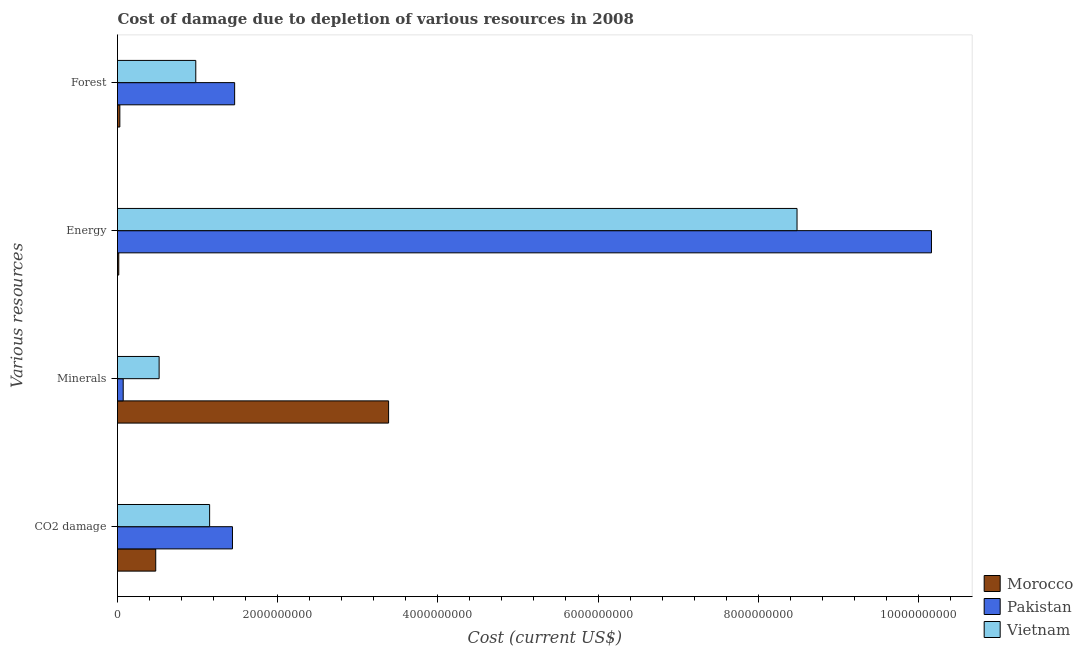How many groups of bars are there?
Provide a succinct answer. 4. Are the number of bars per tick equal to the number of legend labels?
Offer a very short reply. Yes. How many bars are there on the 4th tick from the bottom?
Offer a terse response. 3. What is the label of the 3rd group of bars from the top?
Keep it short and to the point. Minerals. What is the cost of damage due to depletion of forests in Vietnam?
Make the answer very short. 9.77e+08. Across all countries, what is the maximum cost of damage due to depletion of forests?
Provide a short and direct response. 1.46e+09. Across all countries, what is the minimum cost of damage due to depletion of minerals?
Your response must be concise. 7.12e+07. In which country was the cost of damage due to depletion of minerals maximum?
Provide a short and direct response. Morocco. In which country was the cost of damage due to depletion of coal minimum?
Ensure brevity in your answer.  Morocco. What is the total cost of damage due to depletion of forests in the graph?
Your answer should be compact. 2.47e+09. What is the difference between the cost of damage due to depletion of forests in Vietnam and that in Pakistan?
Give a very brief answer. -4.85e+08. What is the difference between the cost of damage due to depletion of minerals in Pakistan and the cost of damage due to depletion of forests in Vietnam?
Offer a very short reply. -9.06e+08. What is the average cost of damage due to depletion of energy per country?
Provide a succinct answer. 6.22e+09. What is the difference between the cost of damage due to depletion of minerals and cost of damage due to depletion of coal in Morocco?
Ensure brevity in your answer.  2.91e+09. What is the ratio of the cost of damage due to depletion of energy in Morocco to that in Vietnam?
Give a very brief answer. 0. Is the cost of damage due to depletion of energy in Pakistan less than that in Morocco?
Make the answer very short. No. What is the difference between the highest and the second highest cost of damage due to depletion of coal?
Give a very brief answer. 2.85e+08. What is the difference between the highest and the lowest cost of damage due to depletion of minerals?
Give a very brief answer. 3.31e+09. In how many countries, is the cost of damage due to depletion of energy greater than the average cost of damage due to depletion of energy taken over all countries?
Provide a short and direct response. 2. Is the sum of the cost of damage due to depletion of energy in Pakistan and Vietnam greater than the maximum cost of damage due to depletion of minerals across all countries?
Provide a succinct answer. Yes. Is it the case that in every country, the sum of the cost of damage due to depletion of energy and cost of damage due to depletion of forests is greater than the sum of cost of damage due to depletion of coal and cost of damage due to depletion of minerals?
Keep it short and to the point. No. What does the 2nd bar from the top in CO2 damage represents?
Make the answer very short. Pakistan. What does the 3rd bar from the bottom in Minerals represents?
Keep it short and to the point. Vietnam. How many countries are there in the graph?
Keep it short and to the point. 3. What is the difference between two consecutive major ticks on the X-axis?
Provide a succinct answer. 2.00e+09. Where does the legend appear in the graph?
Make the answer very short. Bottom right. How many legend labels are there?
Your answer should be compact. 3. How are the legend labels stacked?
Offer a very short reply. Vertical. What is the title of the graph?
Your response must be concise. Cost of damage due to depletion of various resources in 2008 . Does "Turkmenistan" appear as one of the legend labels in the graph?
Provide a short and direct response. No. What is the label or title of the X-axis?
Ensure brevity in your answer.  Cost (current US$). What is the label or title of the Y-axis?
Offer a very short reply. Various resources. What is the Cost (current US$) of Morocco in CO2 damage?
Provide a short and direct response. 4.77e+08. What is the Cost (current US$) of Pakistan in CO2 damage?
Your response must be concise. 1.44e+09. What is the Cost (current US$) of Vietnam in CO2 damage?
Keep it short and to the point. 1.15e+09. What is the Cost (current US$) of Morocco in Minerals?
Your answer should be very brief. 3.38e+09. What is the Cost (current US$) of Pakistan in Minerals?
Offer a very short reply. 7.12e+07. What is the Cost (current US$) in Vietnam in Minerals?
Keep it short and to the point. 5.20e+08. What is the Cost (current US$) of Morocco in Energy?
Provide a short and direct response. 1.57e+07. What is the Cost (current US$) in Pakistan in Energy?
Provide a short and direct response. 1.02e+1. What is the Cost (current US$) of Vietnam in Energy?
Offer a very short reply. 8.48e+09. What is the Cost (current US$) in Morocco in Forest?
Ensure brevity in your answer.  2.91e+07. What is the Cost (current US$) in Pakistan in Forest?
Provide a short and direct response. 1.46e+09. What is the Cost (current US$) of Vietnam in Forest?
Make the answer very short. 9.77e+08. Across all Various resources, what is the maximum Cost (current US$) of Morocco?
Keep it short and to the point. 3.38e+09. Across all Various resources, what is the maximum Cost (current US$) in Pakistan?
Your response must be concise. 1.02e+1. Across all Various resources, what is the maximum Cost (current US$) in Vietnam?
Keep it short and to the point. 8.48e+09. Across all Various resources, what is the minimum Cost (current US$) in Morocco?
Give a very brief answer. 1.57e+07. Across all Various resources, what is the minimum Cost (current US$) of Pakistan?
Your response must be concise. 7.12e+07. Across all Various resources, what is the minimum Cost (current US$) in Vietnam?
Give a very brief answer. 5.20e+08. What is the total Cost (current US$) in Morocco in the graph?
Ensure brevity in your answer.  3.91e+09. What is the total Cost (current US$) in Pakistan in the graph?
Give a very brief answer. 1.31e+1. What is the total Cost (current US$) in Vietnam in the graph?
Provide a succinct answer. 1.11e+1. What is the difference between the Cost (current US$) of Morocco in CO2 damage and that in Minerals?
Provide a succinct answer. -2.91e+09. What is the difference between the Cost (current US$) of Pakistan in CO2 damage and that in Minerals?
Keep it short and to the point. 1.36e+09. What is the difference between the Cost (current US$) of Vietnam in CO2 damage and that in Minerals?
Make the answer very short. 6.30e+08. What is the difference between the Cost (current US$) in Morocco in CO2 damage and that in Energy?
Your answer should be very brief. 4.62e+08. What is the difference between the Cost (current US$) of Pakistan in CO2 damage and that in Energy?
Keep it short and to the point. -8.73e+09. What is the difference between the Cost (current US$) of Vietnam in CO2 damage and that in Energy?
Offer a terse response. -7.33e+09. What is the difference between the Cost (current US$) of Morocco in CO2 damage and that in Forest?
Provide a short and direct response. 4.48e+08. What is the difference between the Cost (current US$) of Pakistan in CO2 damage and that in Forest?
Provide a succinct answer. -2.71e+07. What is the difference between the Cost (current US$) of Vietnam in CO2 damage and that in Forest?
Offer a very short reply. 1.73e+08. What is the difference between the Cost (current US$) in Morocco in Minerals and that in Energy?
Your answer should be very brief. 3.37e+09. What is the difference between the Cost (current US$) of Pakistan in Minerals and that in Energy?
Make the answer very short. -1.01e+1. What is the difference between the Cost (current US$) of Vietnam in Minerals and that in Energy?
Make the answer very short. -7.97e+09. What is the difference between the Cost (current US$) in Morocco in Minerals and that in Forest?
Make the answer very short. 3.36e+09. What is the difference between the Cost (current US$) of Pakistan in Minerals and that in Forest?
Offer a very short reply. -1.39e+09. What is the difference between the Cost (current US$) of Vietnam in Minerals and that in Forest?
Keep it short and to the point. -4.58e+08. What is the difference between the Cost (current US$) of Morocco in Energy and that in Forest?
Give a very brief answer. -1.34e+07. What is the difference between the Cost (current US$) in Pakistan in Energy and that in Forest?
Make the answer very short. 8.70e+09. What is the difference between the Cost (current US$) in Vietnam in Energy and that in Forest?
Provide a succinct answer. 7.51e+09. What is the difference between the Cost (current US$) in Morocco in CO2 damage and the Cost (current US$) in Pakistan in Minerals?
Make the answer very short. 4.06e+08. What is the difference between the Cost (current US$) in Morocco in CO2 damage and the Cost (current US$) in Vietnam in Minerals?
Give a very brief answer. -4.24e+07. What is the difference between the Cost (current US$) in Pakistan in CO2 damage and the Cost (current US$) in Vietnam in Minerals?
Make the answer very short. 9.16e+08. What is the difference between the Cost (current US$) of Morocco in CO2 damage and the Cost (current US$) of Pakistan in Energy?
Offer a very short reply. -9.69e+09. What is the difference between the Cost (current US$) of Morocco in CO2 damage and the Cost (current US$) of Vietnam in Energy?
Offer a terse response. -8.01e+09. What is the difference between the Cost (current US$) of Pakistan in CO2 damage and the Cost (current US$) of Vietnam in Energy?
Provide a short and direct response. -7.05e+09. What is the difference between the Cost (current US$) of Morocco in CO2 damage and the Cost (current US$) of Pakistan in Forest?
Your answer should be very brief. -9.85e+08. What is the difference between the Cost (current US$) in Morocco in CO2 damage and the Cost (current US$) in Vietnam in Forest?
Offer a terse response. -5.00e+08. What is the difference between the Cost (current US$) in Pakistan in CO2 damage and the Cost (current US$) in Vietnam in Forest?
Your answer should be very brief. 4.58e+08. What is the difference between the Cost (current US$) in Morocco in Minerals and the Cost (current US$) in Pakistan in Energy?
Ensure brevity in your answer.  -6.78e+09. What is the difference between the Cost (current US$) of Morocco in Minerals and the Cost (current US$) of Vietnam in Energy?
Offer a terse response. -5.10e+09. What is the difference between the Cost (current US$) in Pakistan in Minerals and the Cost (current US$) in Vietnam in Energy?
Give a very brief answer. -8.41e+09. What is the difference between the Cost (current US$) of Morocco in Minerals and the Cost (current US$) of Pakistan in Forest?
Provide a succinct answer. 1.92e+09. What is the difference between the Cost (current US$) of Morocco in Minerals and the Cost (current US$) of Vietnam in Forest?
Offer a very short reply. 2.41e+09. What is the difference between the Cost (current US$) of Pakistan in Minerals and the Cost (current US$) of Vietnam in Forest?
Your answer should be very brief. -9.06e+08. What is the difference between the Cost (current US$) of Morocco in Energy and the Cost (current US$) of Pakistan in Forest?
Offer a terse response. -1.45e+09. What is the difference between the Cost (current US$) in Morocco in Energy and the Cost (current US$) in Vietnam in Forest?
Offer a terse response. -9.62e+08. What is the difference between the Cost (current US$) in Pakistan in Energy and the Cost (current US$) in Vietnam in Forest?
Make the answer very short. 9.19e+09. What is the average Cost (current US$) in Morocco per Various resources?
Give a very brief answer. 9.77e+08. What is the average Cost (current US$) of Pakistan per Various resources?
Your answer should be compact. 3.28e+09. What is the average Cost (current US$) of Vietnam per Various resources?
Give a very brief answer. 2.78e+09. What is the difference between the Cost (current US$) of Morocco and Cost (current US$) of Pakistan in CO2 damage?
Give a very brief answer. -9.58e+08. What is the difference between the Cost (current US$) in Morocco and Cost (current US$) in Vietnam in CO2 damage?
Offer a terse response. -6.73e+08. What is the difference between the Cost (current US$) of Pakistan and Cost (current US$) of Vietnam in CO2 damage?
Your answer should be compact. 2.85e+08. What is the difference between the Cost (current US$) of Morocco and Cost (current US$) of Pakistan in Minerals?
Make the answer very short. 3.31e+09. What is the difference between the Cost (current US$) in Morocco and Cost (current US$) in Vietnam in Minerals?
Make the answer very short. 2.87e+09. What is the difference between the Cost (current US$) of Pakistan and Cost (current US$) of Vietnam in Minerals?
Your response must be concise. -4.49e+08. What is the difference between the Cost (current US$) in Morocco and Cost (current US$) in Pakistan in Energy?
Give a very brief answer. -1.01e+1. What is the difference between the Cost (current US$) of Morocco and Cost (current US$) of Vietnam in Energy?
Provide a short and direct response. -8.47e+09. What is the difference between the Cost (current US$) of Pakistan and Cost (current US$) of Vietnam in Energy?
Keep it short and to the point. 1.68e+09. What is the difference between the Cost (current US$) in Morocco and Cost (current US$) in Pakistan in Forest?
Offer a terse response. -1.43e+09. What is the difference between the Cost (current US$) of Morocco and Cost (current US$) of Vietnam in Forest?
Keep it short and to the point. -9.48e+08. What is the difference between the Cost (current US$) of Pakistan and Cost (current US$) of Vietnam in Forest?
Make the answer very short. 4.85e+08. What is the ratio of the Cost (current US$) of Morocco in CO2 damage to that in Minerals?
Offer a very short reply. 0.14. What is the ratio of the Cost (current US$) in Pakistan in CO2 damage to that in Minerals?
Make the answer very short. 20.15. What is the ratio of the Cost (current US$) in Vietnam in CO2 damage to that in Minerals?
Your answer should be very brief. 2.21. What is the ratio of the Cost (current US$) in Morocco in CO2 damage to that in Energy?
Keep it short and to the point. 30.33. What is the ratio of the Cost (current US$) of Pakistan in CO2 damage to that in Energy?
Your answer should be very brief. 0.14. What is the ratio of the Cost (current US$) of Vietnam in CO2 damage to that in Energy?
Offer a very short reply. 0.14. What is the ratio of the Cost (current US$) in Morocco in CO2 damage to that in Forest?
Your answer should be very brief. 16.4. What is the ratio of the Cost (current US$) of Pakistan in CO2 damage to that in Forest?
Your answer should be compact. 0.98. What is the ratio of the Cost (current US$) of Vietnam in CO2 damage to that in Forest?
Provide a short and direct response. 1.18. What is the ratio of the Cost (current US$) in Morocco in Minerals to that in Energy?
Offer a very short reply. 215.08. What is the ratio of the Cost (current US$) of Pakistan in Minerals to that in Energy?
Your answer should be compact. 0.01. What is the ratio of the Cost (current US$) of Vietnam in Minerals to that in Energy?
Provide a short and direct response. 0.06. What is the ratio of the Cost (current US$) of Morocco in Minerals to that in Forest?
Your answer should be compact. 116.26. What is the ratio of the Cost (current US$) of Pakistan in Minerals to that in Forest?
Provide a short and direct response. 0.05. What is the ratio of the Cost (current US$) of Vietnam in Minerals to that in Forest?
Provide a short and direct response. 0.53. What is the ratio of the Cost (current US$) of Morocco in Energy to that in Forest?
Provide a short and direct response. 0.54. What is the ratio of the Cost (current US$) in Pakistan in Energy to that in Forest?
Make the answer very short. 6.95. What is the ratio of the Cost (current US$) of Vietnam in Energy to that in Forest?
Provide a succinct answer. 8.68. What is the difference between the highest and the second highest Cost (current US$) of Morocco?
Offer a very short reply. 2.91e+09. What is the difference between the highest and the second highest Cost (current US$) of Pakistan?
Make the answer very short. 8.70e+09. What is the difference between the highest and the second highest Cost (current US$) in Vietnam?
Your response must be concise. 7.33e+09. What is the difference between the highest and the lowest Cost (current US$) in Morocco?
Give a very brief answer. 3.37e+09. What is the difference between the highest and the lowest Cost (current US$) of Pakistan?
Offer a very short reply. 1.01e+1. What is the difference between the highest and the lowest Cost (current US$) in Vietnam?
Your response must be concise. 7.97e+09. 